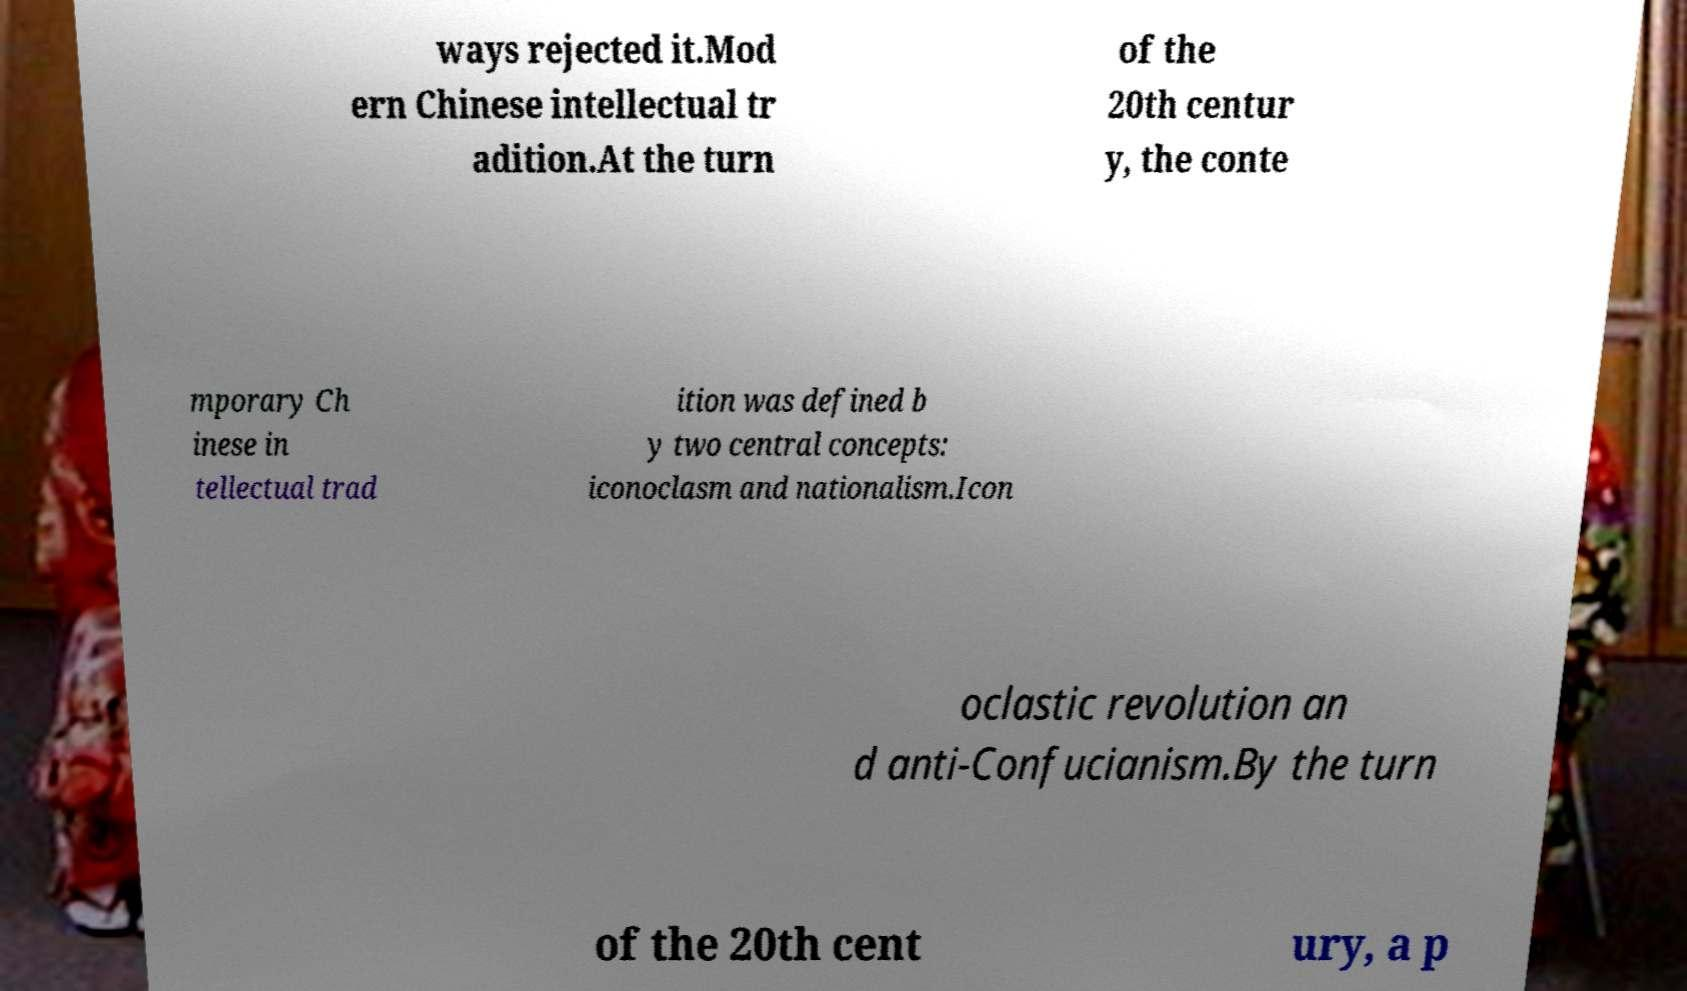Please identify and transcribe the text found in this image. ways rejected it.Mod ern Chinese intellectual tr adition.At the turn of the 20th centur y, the conte mporary Ch inese in tellectual trad ition was defined b y two central concepts: iconoclasm and nationalism.Icon oclastic revolution an d anti-Confucianism.By the turn of the 20th cent ury, a p 